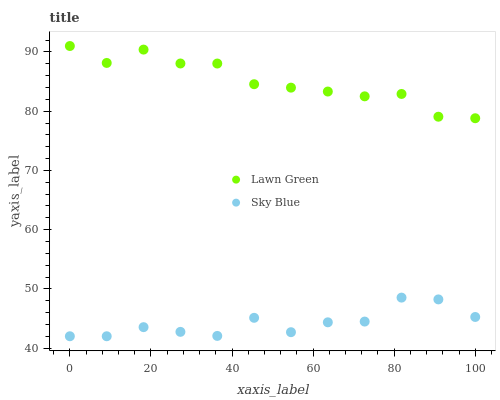Does Sky Blue have the minimum area under the curve?
Answer yes or no. Yes. Does Lawn Green have the maximum area under the curve?
Answer yes or no. Yes. Does Sky Blue have the maximum area under the curve?
Answer yes or no. No. Is Lawn Green the smoothest?
Answer yes or no. Yes. Is Sky Blue the roughest?
Answer yes or no. Yes. Is Sky Blue the smoothest?
Answer yes or no. No. Does Sky Blue have the lowest value?
Answer yes or no. Yes. Does Lawn Green have the highest value?
Answer yes or no. Yes. Does Sky Blue have the highest value?
Answer yes or no. No. Is Sky Blue less than Lawn Green?
Answer yes or no. Yes. Is Lawn Green greater than Sky Blue?
Answer yes or no. Yes. Does Sky Blue intersect Lawn Green?
Answer yes or no. No. 